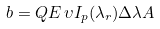<formula> <loc_0><loc_0><loc_500><loc_500>b = Q E \, \upsilon I _ { p } ( \lambda _ { r } ) \Delta \lambda A</formula> 